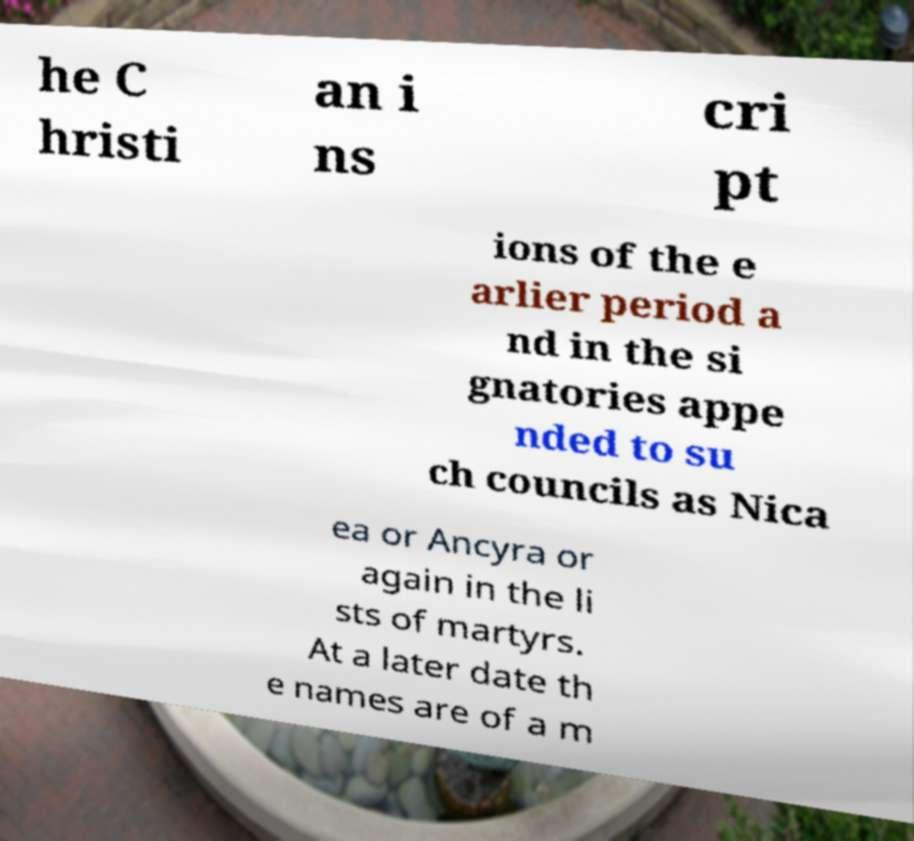Can you read and provide the text displayed in the image?This photo seems to have some interesting text. Can you extract and type it out for me? he C hristi an i ns cri pt ions of the e arlier period a nd in the si gnatories appe nded to su ch councils as Nica ea or Ancyra or again in the li sts of martyrs. At a later date th e names are of a m 